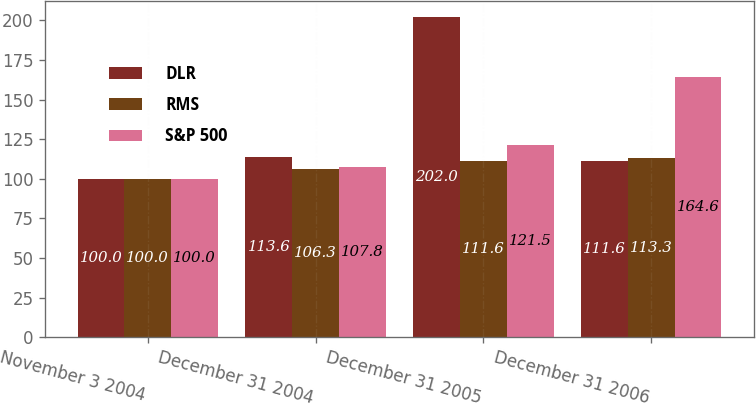<chart> <loc_0><loc_0><loc_500><loc_500><stacked_bar_chart><ecel><fcel>November 3 2004<fcel>December 31 2004<fcel>December 31 2005<fcel>December 31 2006<nl><fcel>DLR<fcel>100<fcel>113.6<fcel>202<fcel>111.6<nl><fcel>RMS<fcel>100<fcel>106.3<fcel>111.6<fcel>113.3<nl><fcel>S&P 500<fcel>100<fcel>107.8<fcel>121.5<fcel>164.6<nl></chart> 